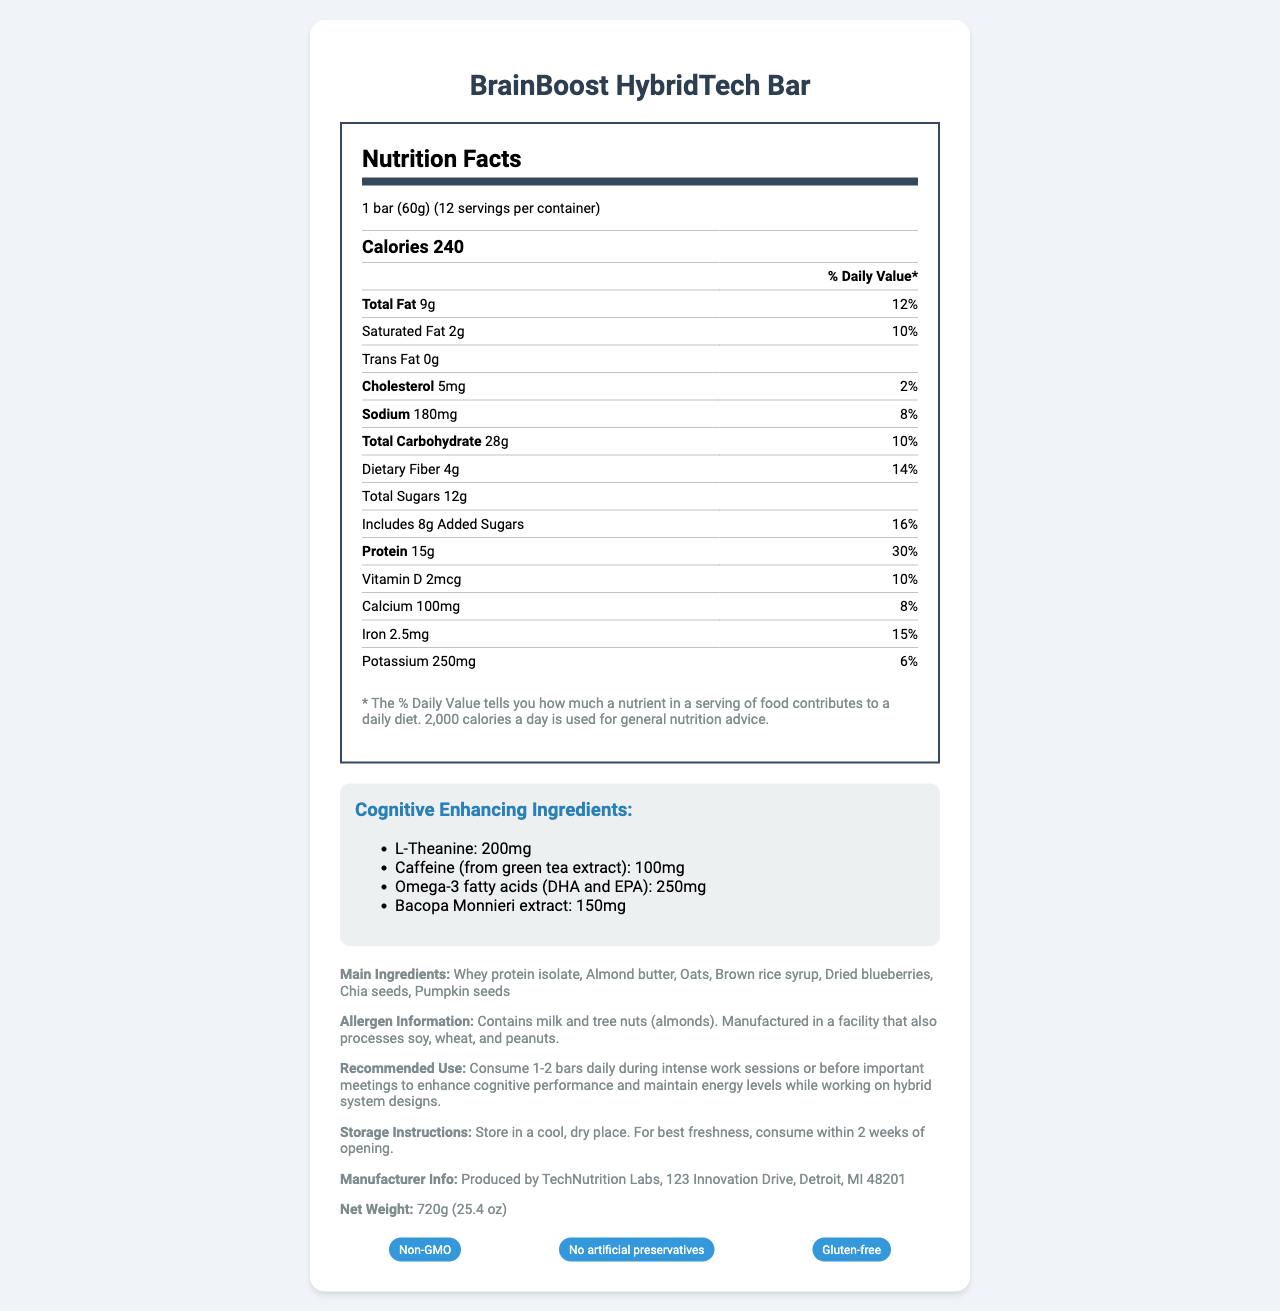what is the product name? The product name is clearly stated at the beginning of the document.
Answer: BrainBoost HybridTech Bar how many servings are there per container? The document specifies that there are 12 servings per container.
Answer: 12 what is the amount of saturated fat per serving? The document shows the amount of saturated fat is 2g per serving.
Answer: 2g what is the daily value percentage of dietary fiber per serving? The document indicates that the daily value percentage of dietary fiber per serving is 14%.
Answer: 14% what is the total amount of protein in one serving? It is stated that one serving contains 15g of protein.
Answer: 15g which of the following is not a cognitive-enhancing ingredient in the bar? A. L-Theanine B. Caffeine C. Choline D. Omega-3 fatty acids The document lists L-Theanine, Caffeine, and Omega-3 fatty acids as cognitive-enhancing ingredients but does not mention Choline.
Answer: C. Choline how much calcium is in one serving? A. 50mg B. 100mg C. 200mg D. 250mg The document specifies that one serving contains 100mg of calcium.
Answer: B. 100mg does the product contain any trans fats? The document states trans fats are 0g.
Answer: No is this product suitable for someone with a peanut allergy? The document's allergen information mentions that the bar is manufactured in a facility that also processes soy, wheat, and peanuts.
Answer: No provide a summary of the document. The document gives a comprehensive overview of the nutritional content and special features of the BrainBoost HybridTech Bar, aimed to support cognitive performance.
Answer: This document describes the nutritional information, ingredients, and additional features of the BrainBoost HybridTech Bar. Each bar has 240 calories and provides various nutrients like protein, dietary fiber, and calcium, alongside cognitive-enhancing ingredients such as L-Theanine and Omega-3 fatty acids. The bar is non-GMO, gluten-free, and does not contain artificial preservatives. Allergen information is also provided, stating the inclusion of milk and tree nuts and potential traces of other allergens. how much sodium is in one serving? The document lists 180mg of sodium per serving.
Answer: 180mg list two special features of the product. The document states that the product is Non-GMO and Gluten-free.
Answer: Non-GMO, Gluten-free how much vitamin D is present in one serving? The document reports that one serving includes 2mcg of Vitamin D.
Answer: 2mcg are there any artificial preservatives in the bar? The document explicitly mentions that the bar contains no artificial preservatives.
Answer: No how should the product be stored? The storage instructions provided in the document specify that the bar should be kept in a cool, dry place and consumed within 2 weeks of opening.
Answer: Store in a cool, dry place. For best freshness, consume within 2 weeks of opening. does this bar include ingredients that help enhance cognitive performance? The document mentions cognitive-enhancing ingredients like L-Theanine, Caffeine, Omega-3 fatty acids, and Bacopa Monnieri extract.
Answer: Yes what is the net weight of the product? The document specifies the net weight as 720g (25.4 oz).
Answer: 720g (25.4 oz) how much of the total sugars are added sugars? According to the document, 8g of the total 12g sugars are added sugars.
Answer: 8g is this bar recommended for athletes? The document does not provide explicit recommendations for athletes, only recommendations for cognitive performance during intense work sessions.
Answer: Cannot be determined who manufactures the BrainBoost HybridTech Bar? The manufacturer is listed as TechNutrition Labs, located at 123 Innovation Drive, Detroit, MI 48201.
Answer: TechNutrition Labs 